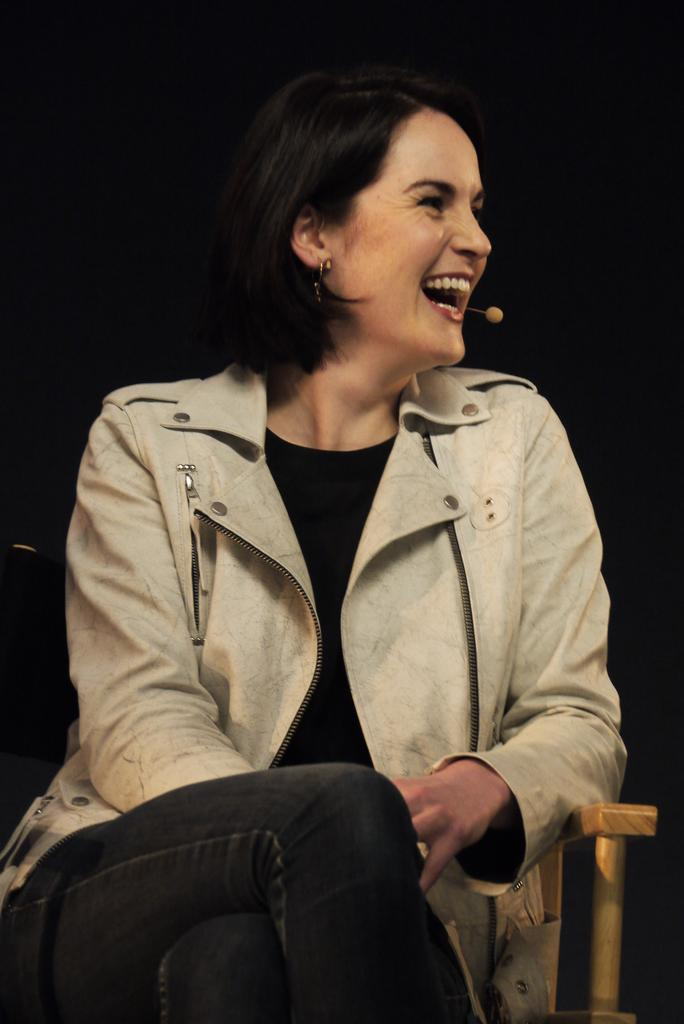Who is the main subject in the image? There is a lady in the image. What is the lady holding in the image? The lady is holding a mic. What is the lady's position in the image? The lady is sitting on a chair. What can be observed about the background of the image? The background of the image is dark. Reasoning: Let's think step by step by breaking down the information provided step by step. We start by identifying the main subject, which is the lady. Then, we describe what she is doing, which is holding a mic and sitting on a chair. Finally, we mention the background of the image, which is dark. Each question is designed to provide specific details about the image based on the given facts. Absurd Question/Answer: How many answers can be found on the ground in the image? There is no mention of answers or the ground in the image, so it cannot be determined. 